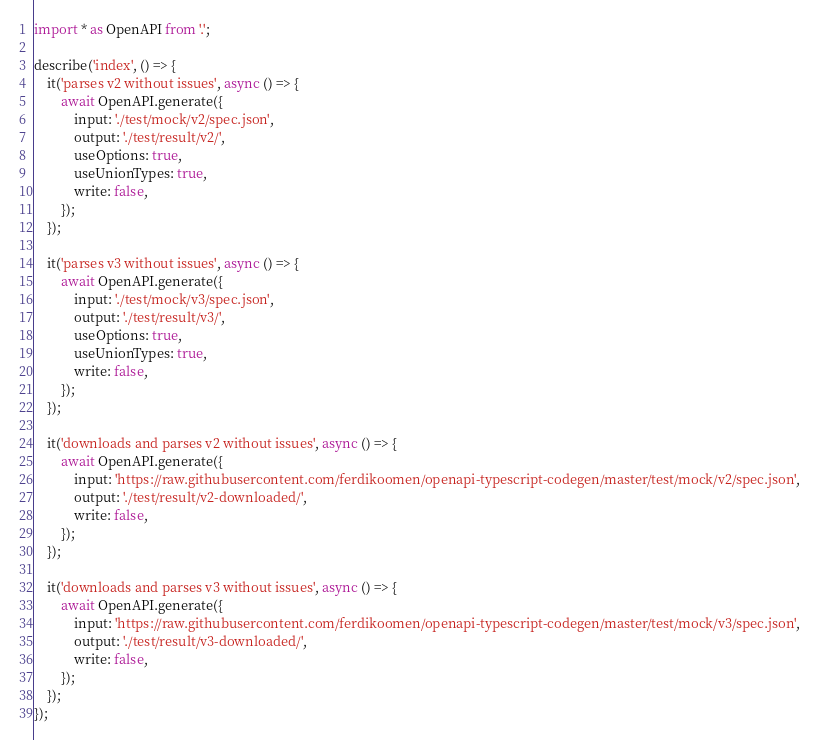<code> <loc_0><loc_0><loc_500><loc_500><_TypeScript_>import * as OpenAPI from '.';

describe('index', () => {
    it('parses v2 without issues', async () => {
        await OpenAPI.generate({
            input: './test/mock/v2/spec.json',
            output: './test/result/v2/',
            useOptions: true,
            useUnionTypes: true,
            write: false,
        });
    });

    it('parses v3 without issues', async () => {
        await OpenAPI.generate({
            input: './test/mock/v3/spec.json',
            output: './test/result/v3/',
            useOptions: true,
            useUnionTypes: true,
            write: false,
        });
    });

    it('downloads and parses v2 without issues', async () => {
        await OpenAPI.generate({
            input: 'https://raw.githubusercontent.com/ferdikoomen/openapi-typescript-codegen/master/test/mock/v2/spec.json',
            output: './test/result/v2-downloaded/',
            write: false,
        });
    });

    it('downloads and parses v3 without issues', async () => {
        await OpenAPI.generate({
            input: 'https://raw.githubusercontent.com/ferdikoomen/openapi-typescript-codegen/master/test/mock/v3/spec.json',
            output: './test/result/v3-downloaded/',
            write: false,
        });
    });
});
</code> 